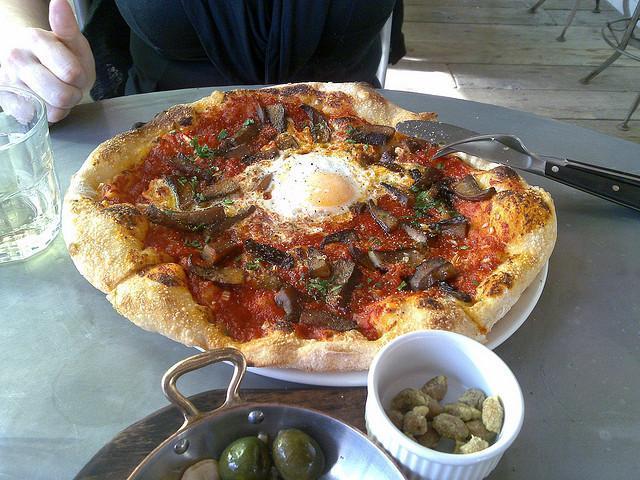Does the caption "The pizza is on top of the dining table." correctly depict the image?
Answer yes or no. Yes. 